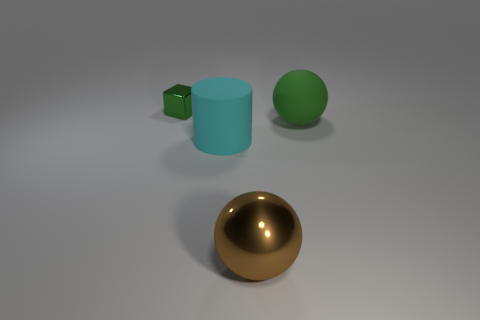Add 3 tiny objects. How many objects exist? 7 Subtract all cylinders. How many objects are left? 3 Subtract 0 red cubes. How many objects are left? 4 Subtract all green cubes. Subtract all large blocks. How many objects are left? 3 Add 3 rubber spheres. How many rubber spheres are left? 4 Add 3 cyan matte cylinders. How many cyan matte cylinders exist? 4 